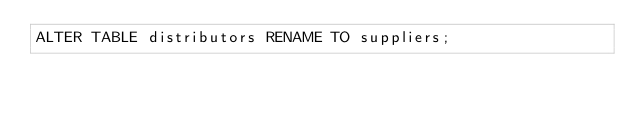Convert code to text. <code><loc_0><loc_0><loc_500><loc_500><_SQL_>ALTER TABLE distributors RENAME TO suppliers;
</code> 